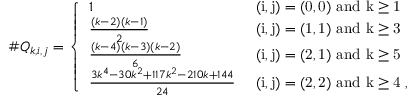Convert formula to latex. <formula><loc_0><loc_0><loc_500><loc_500>\# Q _ { k , i , j } = \left \{ \begin{array} { l l } { 1 } & { ( i , j ) = ( 0 , 0 ) a n d k \geq 1 } \\ { \frac { ( k - 2 ) ( k - 1 ) } { 2 } } & { ( i , j ) = ( 1 , 1 ) a n d k \geq 3 } \\ { \frac { ( k - 4 ) ( k - 3 ) ( k - 2 ) } { 6 } } & { ( i , j ) = ( 2 , 1 ) a n d k \geq 5 } \\ { \frac { 3 k ^ { 4 } - 3 0 k ^ { 2 } + 1 1 7 k ^ { 2 } - 2 1 0 k + 1 4 4 } { 2 4 } } & { ( i , j ) = ( 2 , 2 ) a n d k \geq 4 , } \end{array}</formula> 